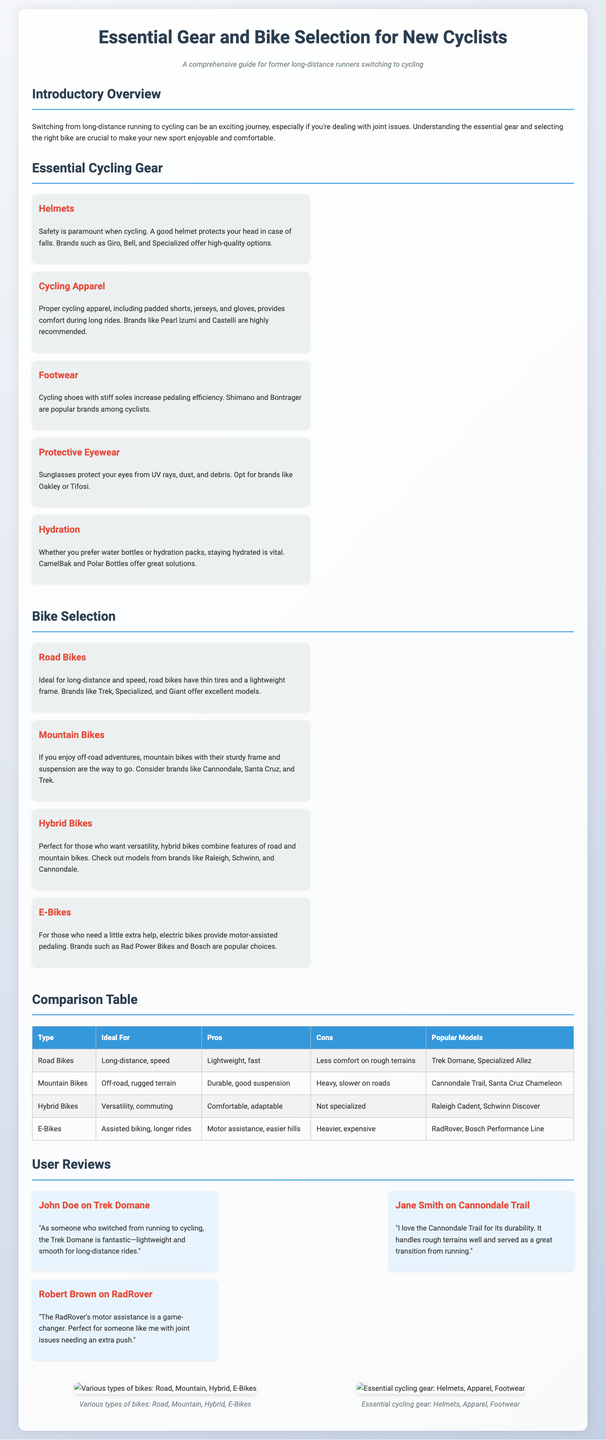What are the recommended brands for helmets? The document lists Giro, Bell, and Specialized as high-quality helmet brands.
Answer: Giro, Bell, Specialized What type of biking is ideal for road bikes? The document states that road bikes are ideal for long-distance and speed biking.
Answer: Long-distance, speed Which bike is designed for off-road adventures? The document specifies that mountain bikes are designed for off-road adventures with sturdy frames and suspension.
Answer: Mountain Bikes What are two main benefits of e-bikes? According to the document, e-bikes offer motor assistance and easier hill climbs as primary benefits.
Answer: Motor assistance, easier hills Which item provides comfort during long rides? The document indicates that padded shorts are part of cycling apparel, which helps provide comfort during long rides.
Answer: Padded shorts What company model is highlighted for being lightweight and smooth for long-distance rides? The document features the Trek Domane as a model that is lightweight and smooth for long-distance cycling.
Answer: Trek Domane What is the ideal hybrid bike type for? The document explains that hybrid bikes are perfect for versatility and commuting.
Answer: Versatility, commuting Which cycling gear helps protect eyes from UV rays? The document mentions protective eyewear as the gear that helps protect eyes from UV rays, dust, and debris.
Answer: Protective eyewear Who reviewed the RadRover and what was their opinion? The document mentions Robert Brown reviewing the RadRover and describes its motor assistance as a game-changer for joint issues.
Answer: Robert Brown, game-changer 